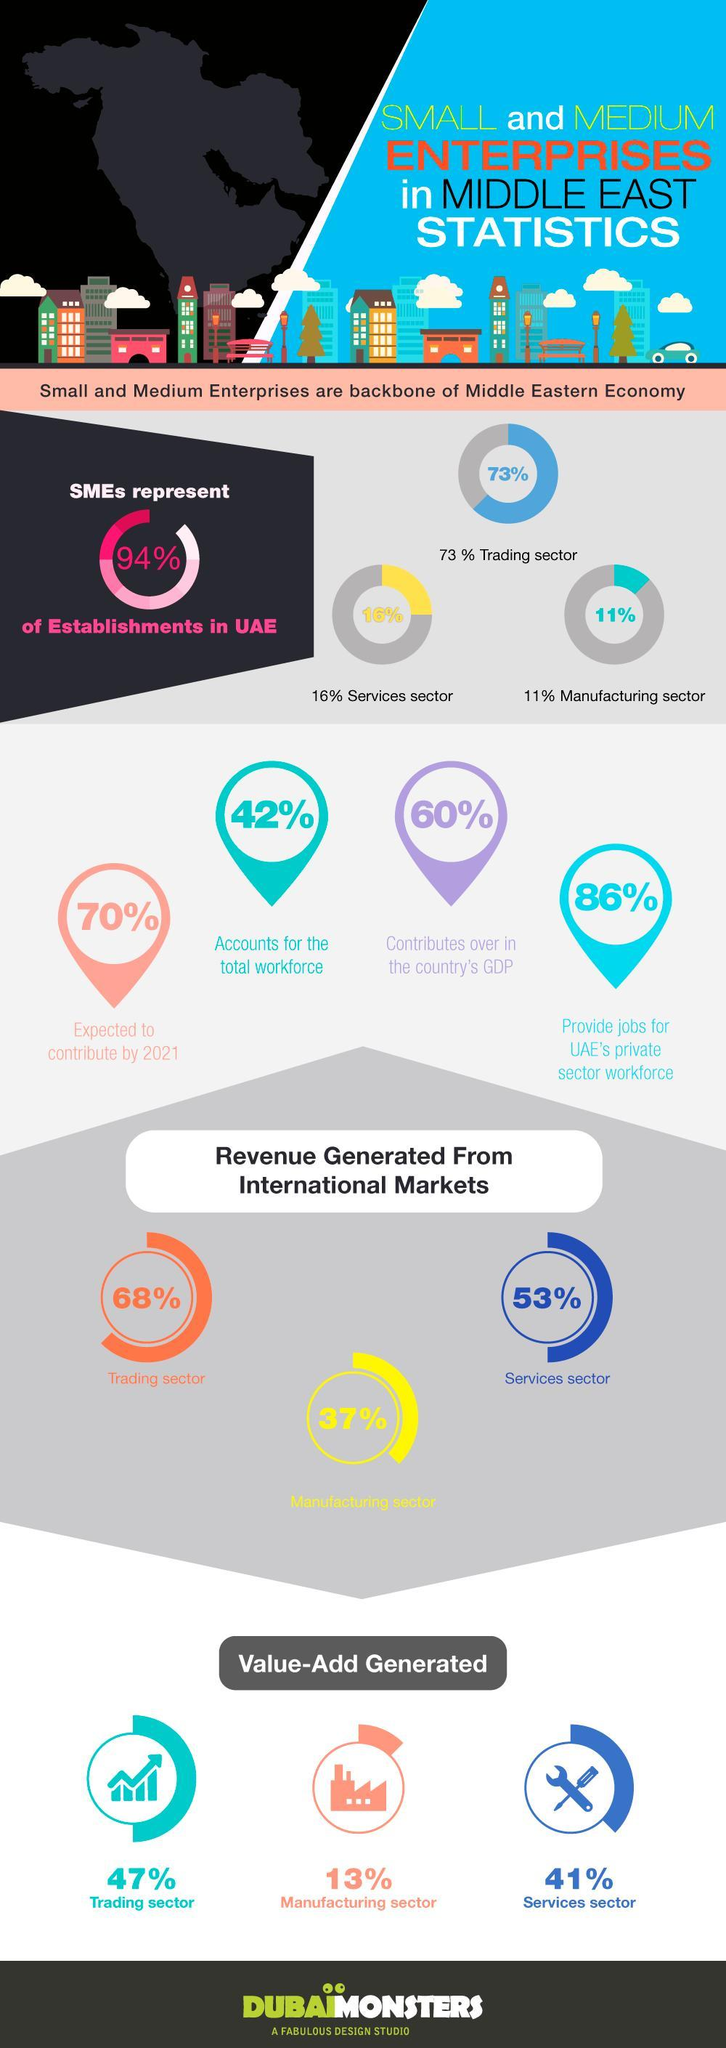What is the value add generated for the manufacturing sector?
Answer the question with a short phrase. 13% What percentage of enterprises in middle east are not in the Services sector? 84 What is the inverse of value add generated in the trading sector? 53 What is the inverse of revenue generated in the manufacturing sector? 63 Enterprises in Middle East are classified into how many different sectors? 3 What percentage of Enterprises in Middle East are not SMEs? 6 What percentage of enterprises in middle east are not in the trading sector? 27 What is the value add generated for the Services sector? 41% What is the revenue generated from international Markets for the Services sector? 53% What percentage of enterprises in middle east are not in the manufacturing sector? 89 